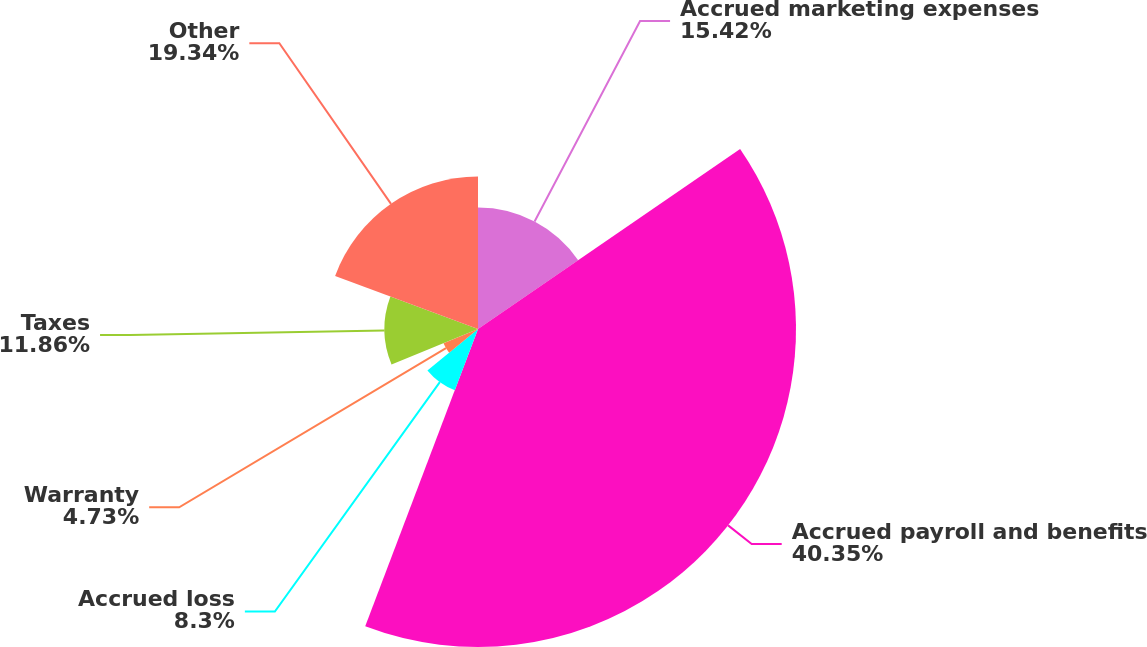Convert chart. <chart><loc_0><loc_0><loc_500><loc_500><pie_chart><fcel>Accrued marketing expenses<fcel>Accrued payroll and benefits<fcel>Accrued loss<fcel>Warranty<fcel>Taxes<fcel>Other<nl><fcel>15.42%<fcel>40.35%<fcel>8.3%<fcel>4.73%<fcel>11.86%<fcel>19.34%<nl></chart> 